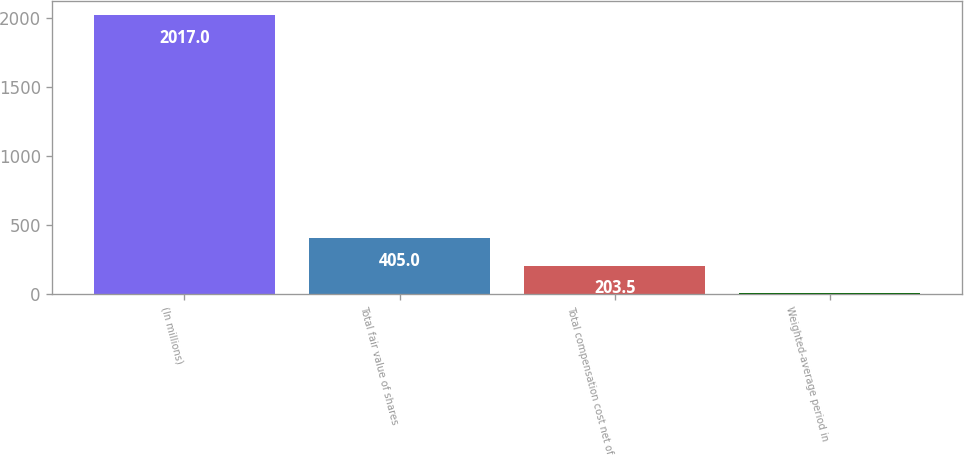Convert chart to OTSL. <chart><loc_0><loc_0><loc_500><loc_500><bar_chart><fcel>(In millions)<fcel>Total fair value of shares<fcel>Total compensation cost net of<fcel>Weighted-average period in<nl><fcel>2017<fcel>405<fcel>203.5<fcel>2<nl></chart> 